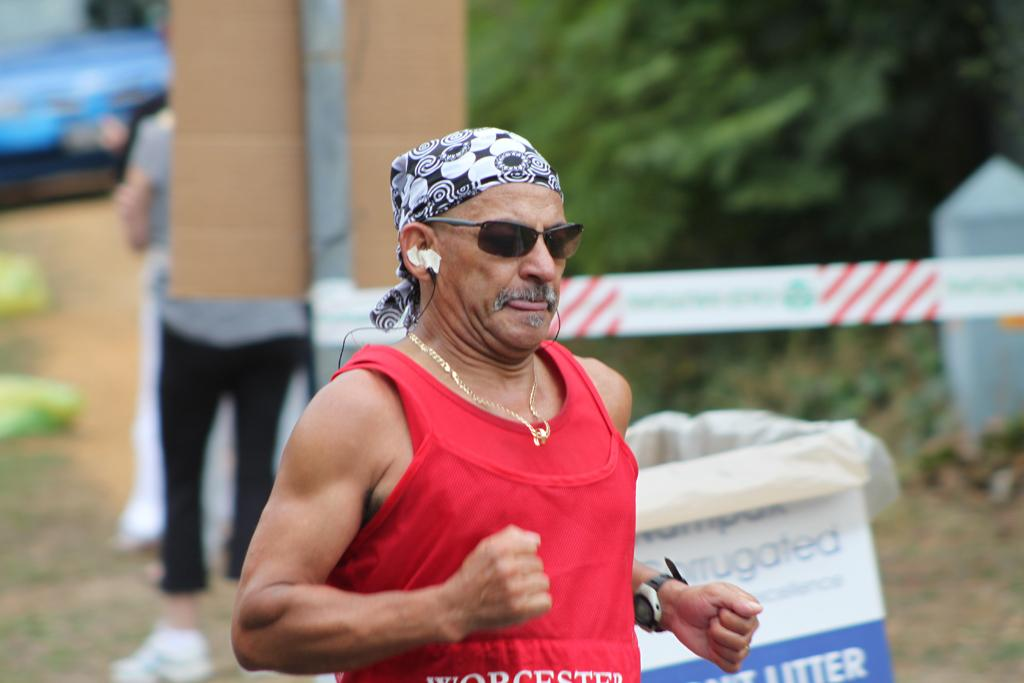What is the man in the image wearing? The man is wearing a red t-shirt in the image. What is the man doing in the image? The man is running on a path in the image. Can you describe the person behind the man? There is another person standing behind the man in the image. What type of natural environment can be seen in the image? Trees are visible in the image. What is the condition of the background in the image? There are some blurred things in the background of the image. How many carriages can be seen in the image? There are no carriages present in the image. What type of toy is the man playing with in the image? There is no toy visible in the image; the man is running on a path. 